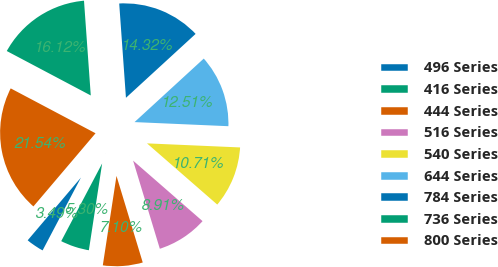Convert chart to OTSL. <chart><loc_0><loc_0><loc_500><loc_500><pie_chart><fcel>496 Series<fcel>416 Series<fcel>444 Series<fcel>516 Series<fcel>540 Series<fcel>644 Series<fcel>784 Series<fcel>736 Series<fcel>800 Series<nl><fcel>3.49%<fcel>5.3%<fcel>7.1%<fcel>8.91%<fcel>10.71%<fcel>12.51%<fcel>14.32%<fcel>16.12%<fcel>21.54%<nl></chart> 